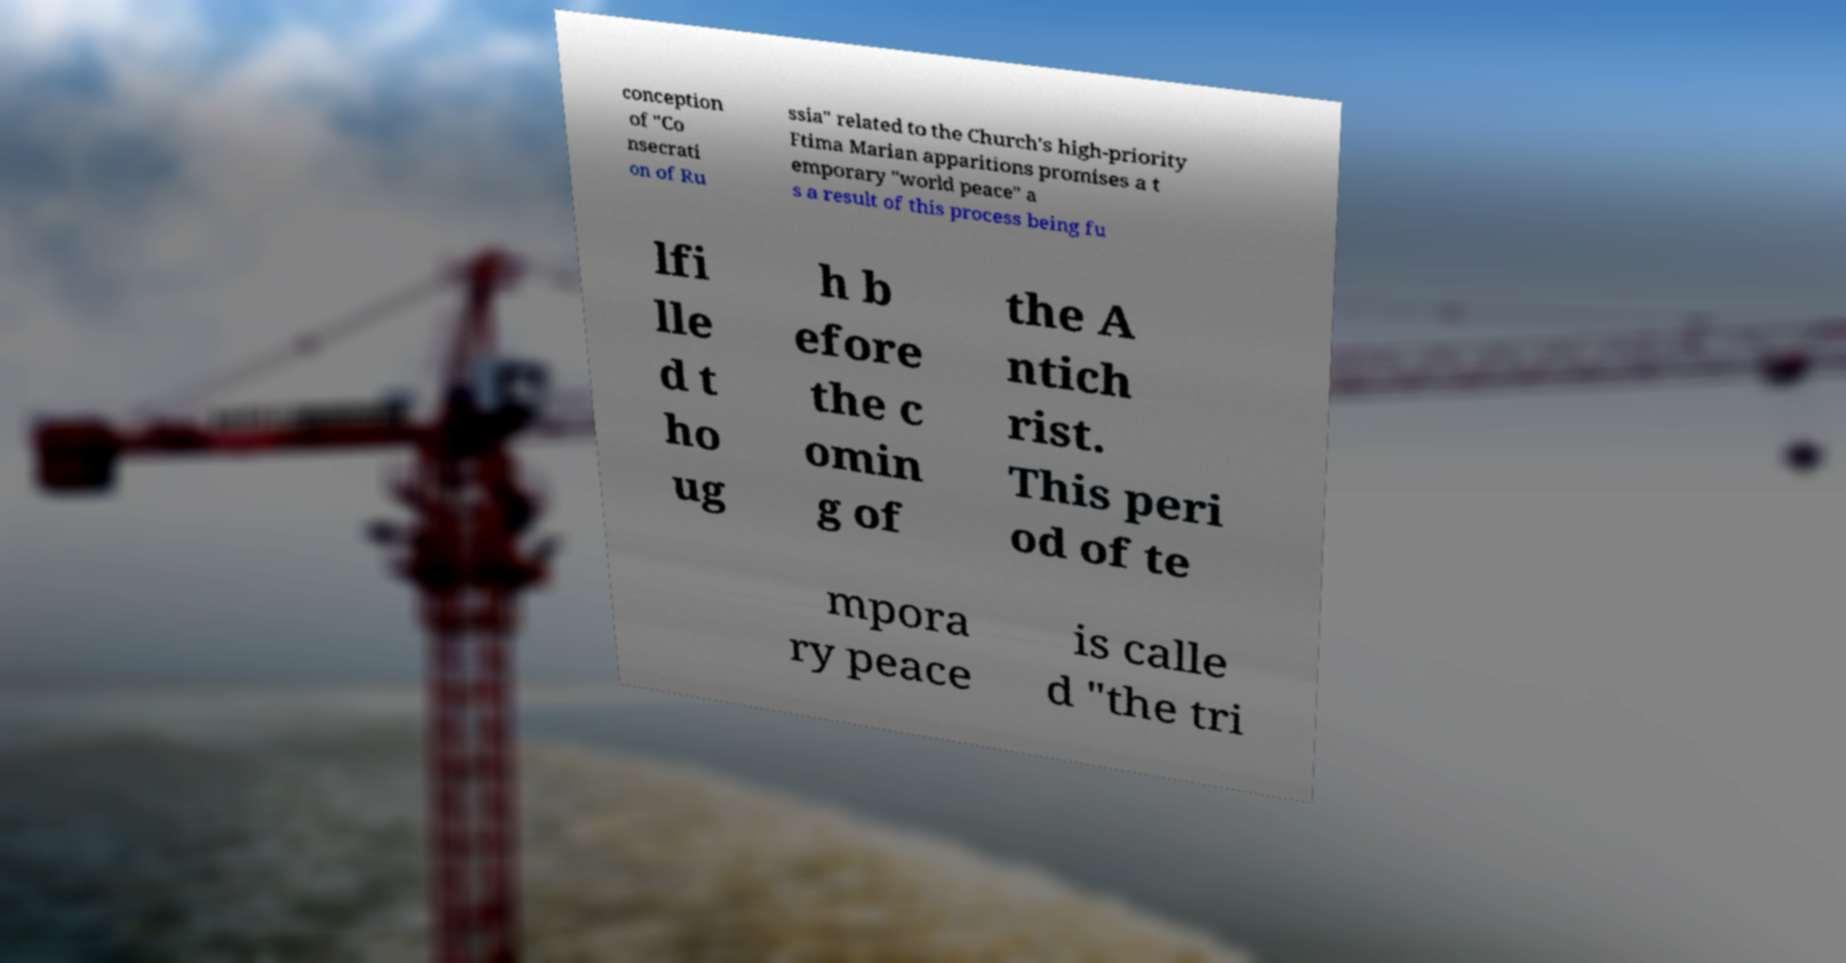Can you accurately transcribe the text from the provided image for me? conception of "Co nsecrati on of Ru ssia" related to the Church's high-priority Ftima Marian apparitions promises a t emporary "world peace" a s a result of this process being fu lfi lle d t ho ug h b efore the c omin g of the A ntich rist. This peri od of te mpora ry peace is calle d "the tri 